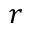<formula> <loc_0><loc_0><loc_500><loc_500>r</formula> 